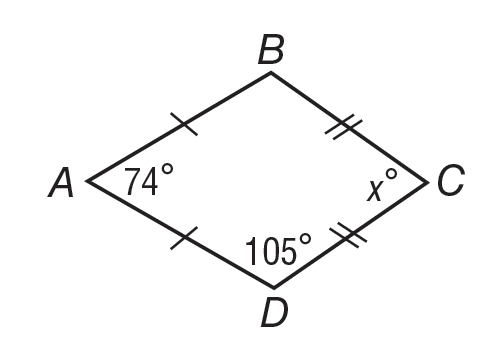Question: If quadrilateral A B C D is a kite, what is m \angle C?
Choices:
A. 15
B. 74
C. 76
D. 89
Answer with the letter. Answer: C 